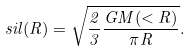<formula> <loc_0><loc_0><loc_500><loc_500>\ s i l ( R ) = \sqrt { \frac { 2 } { 3 } \frac { G M ( < R ) } { \pi R } } .</formula> 